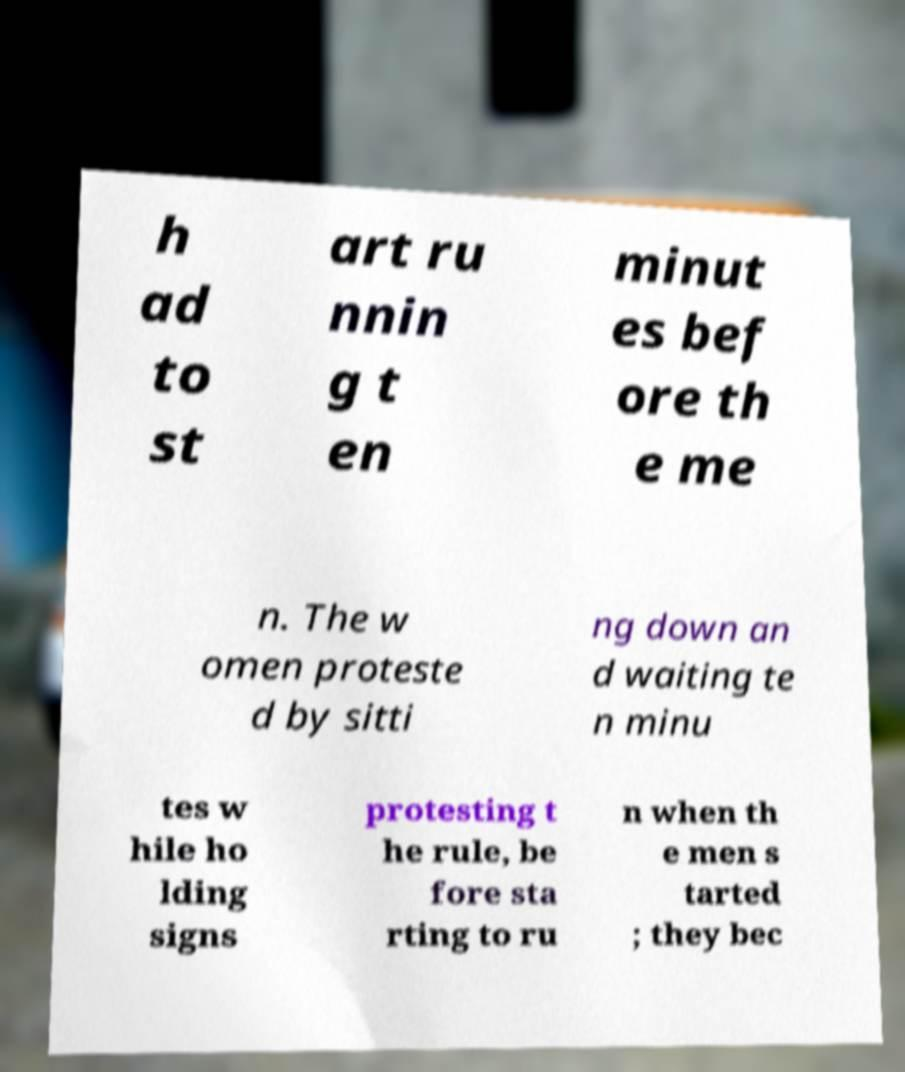Could you assist in decoding the text presented in this image and type it out clearly? h ad to st art ru nnin g t en minut es bef ore th e me n. The w omen proteste d by sitti ng down an d waiting te n minu tes w hile ho lding signs protesting t he rule, be fore sta rting to ru n when th e men s tarted ; they bec 